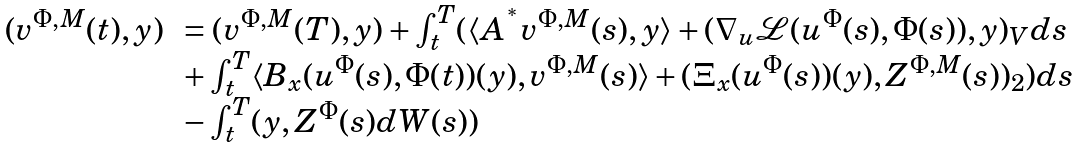<formula> <loc_0><loc_0><loc_500><loc_500>\begin{array} { r l } ( v ^ { \Phi , M } ( t ) , y ) \, & = ( v ^ { \Phi , M } ( T ) , y ) + \int ^ { T } _ { t } ( \langle A ^ { ^ { * } } v ^ { \Phi , M } ( s ) , y \rangle + ( \nabla _ { u } \mathcal { L } ( u ^ { \Phi } ( s ) , \Phi ( s ) ) , y ) _ { V } d s \\ \, & + \int ^ { T } _ { t } \langle B _ { x } ( u ^ { \Phi } ( s ) , \Phi ( t ) ) ( y ) , v ^ { \Phi , M } ( s ) \rangle + ( \Xi _ { x } ( u ^ { \Phi } ( s ) ) ( y ) , Z ^ { \Phi , M } ( s ) ) _ { 2 } ) d s \\ & - \int ^ { T } _ { t } ( y , Z ^ { \Phi } ( s ) d W ( s ) ) \end{array}</formula> 